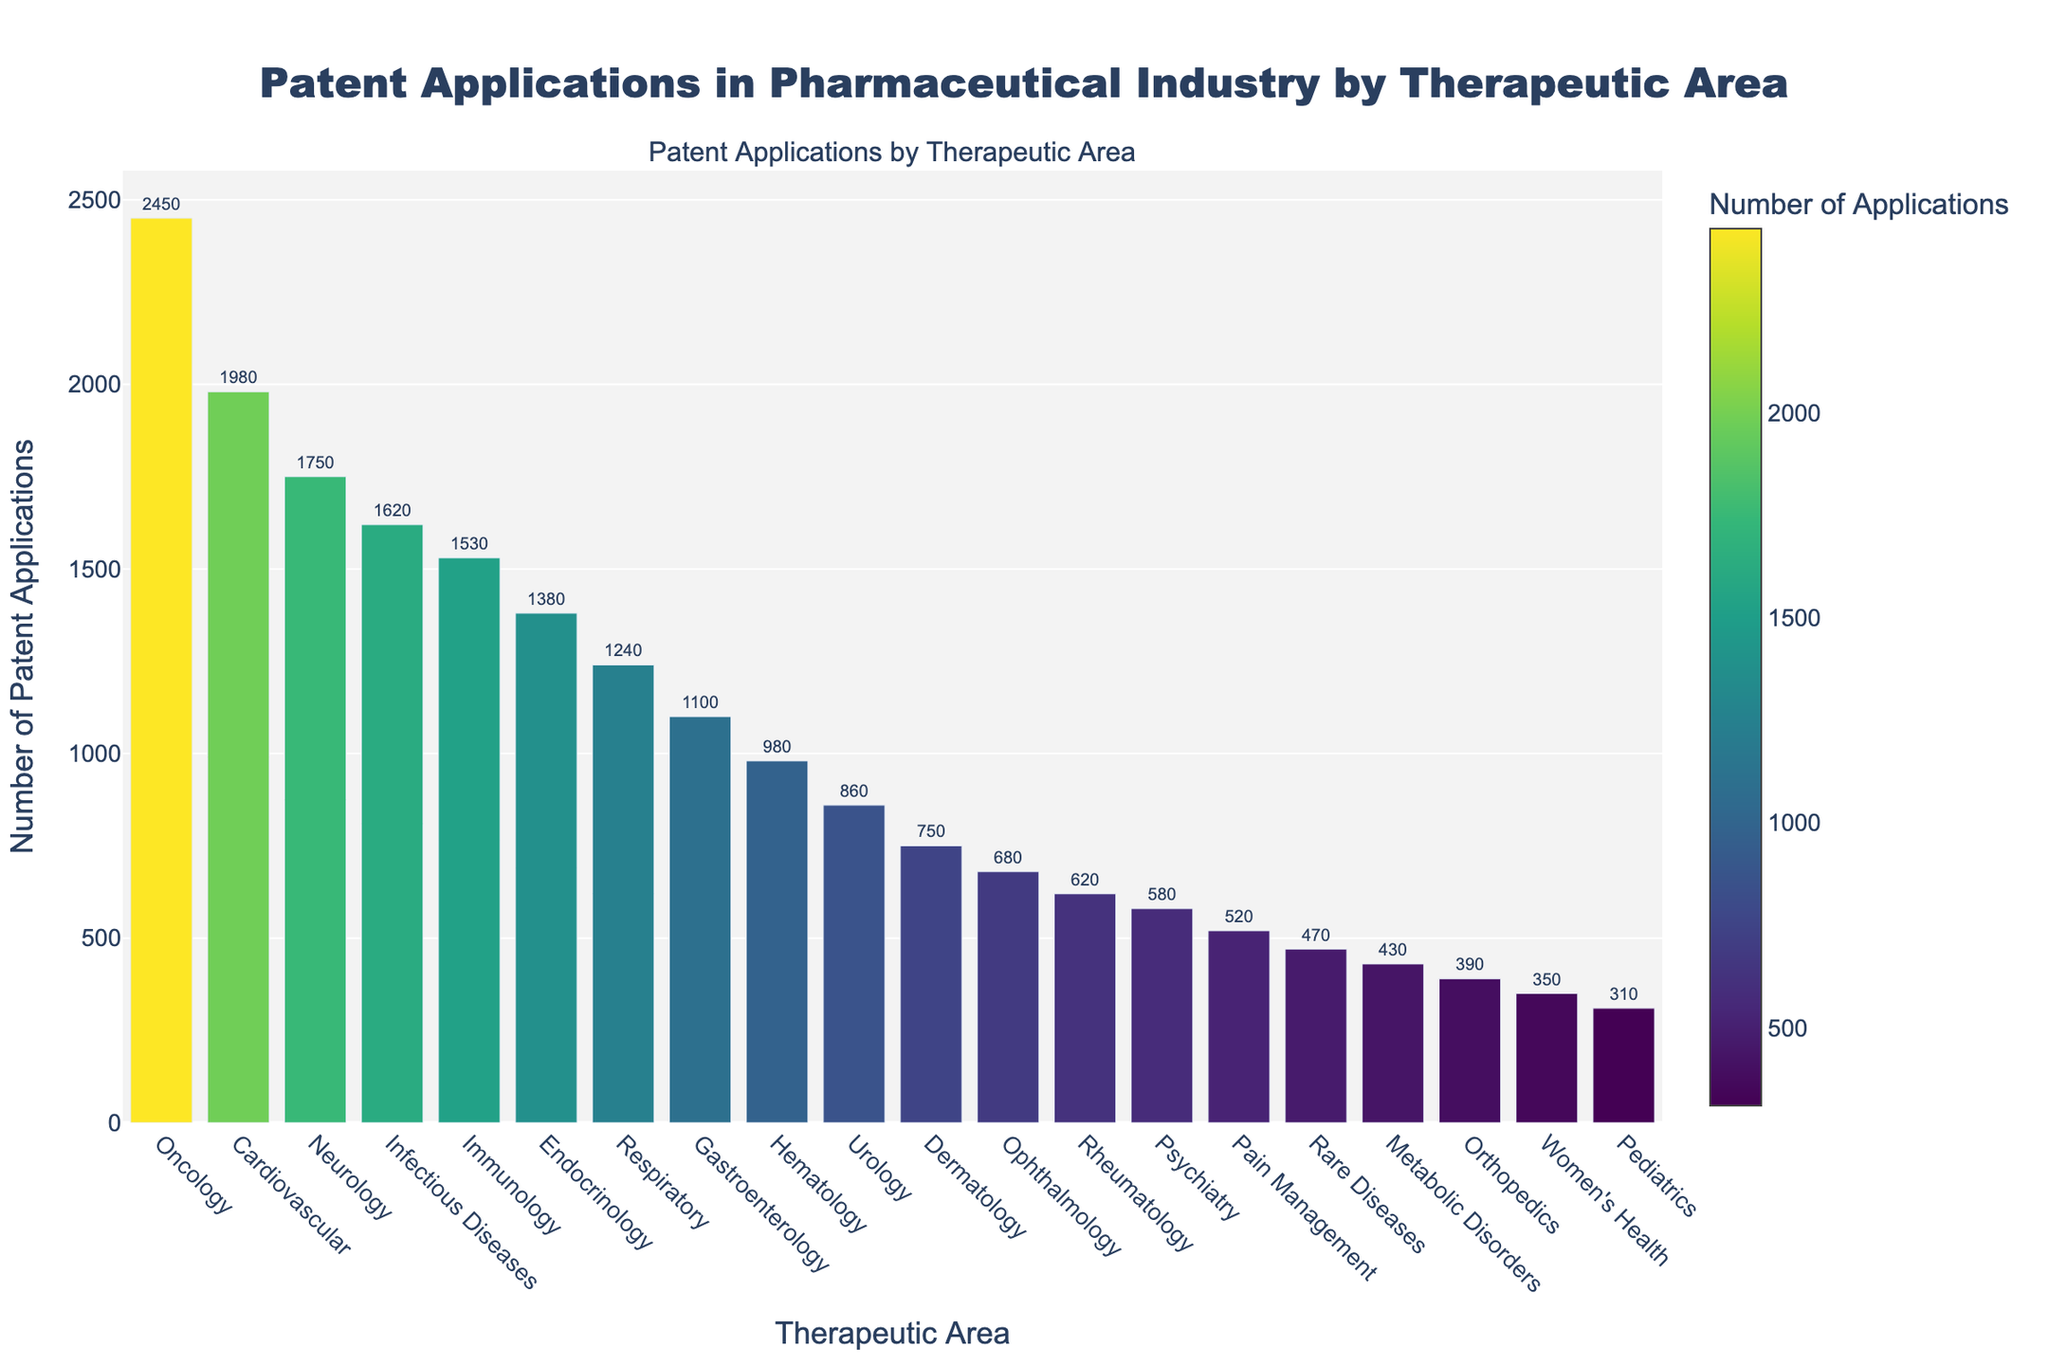Which therapeutic area has the highest number of patent applications? The bar representing Oncology is the highest, indicating it has the most patent applications.
Answer: Oncology Which therapeutic area has the least number of patent applications? The bar representing Pediatrics is the shortest, indicating it has the fewest patent applications.
Answer: Pediatrics How many more patent applications does Oncology have compared to Neurology? Oncology has 2450 applications, and Neurology has 1750. The difference is 2450 - 1750 = 700.
Answer: 700 What is the average number of patent applications in Immunology, Endocrinology, and Gastroenterology? Immunology has 1530, Endocrinology has 1380, and Gastroenterology has 1100. The average is (1530 + 1380 + 1100) / 3 = 1336.67.
Answer: 1336.67 Do the therapeutic areas with more than 2000 patent applications have similar or different colors to each other? The colors of the bars representing Oncology and Cardiovascular (both above 2000 applications) are different shades, indicating different values on the color scale.
Answer: Different colors Which therapeutic areas have patent applications that are less than 1000? Hematology, Urology, Dermatology, Ophthalmology, Rheumatology, Psychiatry, Pain Management, Rare Diseases, Metabolic Disorders, Orthopedics, Women's Health, and Pediatrics have less than 1000 applications.
Answer: Hematology, Urology, Dermatology, Ophthalmology, Rheumatology, Psychiatry, Pain Management, Rare Diseases, Metabolic Disorders, Orthopedics, Women's Health, Pediatrics Is the number of patent applications for Respiratory more or less than the combined applications for Urology and Orthopedics? Respiratory has 1240 applications. Urology has 860, and Orthopedics has 390. The combined total is 860 + 390 = 1250. Therefore, Respiratory has fewer applications.
Answer: Less What is the range of patent applications across all therapeutic areas? The range is calculated by subtracting the smallest number of applications (Pediatrics with 310) from the largest (Oncology with 2450), which is 2450 - 310 = 2140.
Answer: 2140 Are there more therapeutic areas with patent applications above or below the median number of applications? The median can be found by sorting the number of applications and identifying the middle value. In this case, the median value falls between Gastroenterology (1100) and Hematology (980). There are 10 areas above the median (including Gastroenterology) and 10 areas below it.
Answer: Equal 